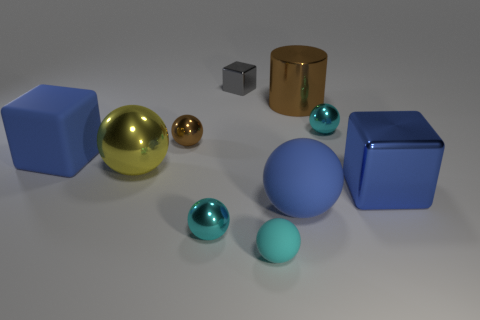Subtract all cyan spheres. How many were subtracted if there are1cyan spheres left? 2 Subtract all yellow spheres. How many spheres are left? 5 Subtract all large rubber blocks. How many blocks are left? 2 Subtract 0 purple cubes. How many objects are left? 10 Subtract all balls. How many objects are left? 4 Subtract 4 balls. How many balls are left? 2 Subtract all green cubes. Subtract all brown spheres. How many cubes are left? 3 Subtract all blue balls. How many gray cubes are left? 1 Subtract all shiny things. Subtract all shiny cylinders. How many objects are left? 2 Add 6 yellow metal balls. How many yellow metal balls are left? 7 